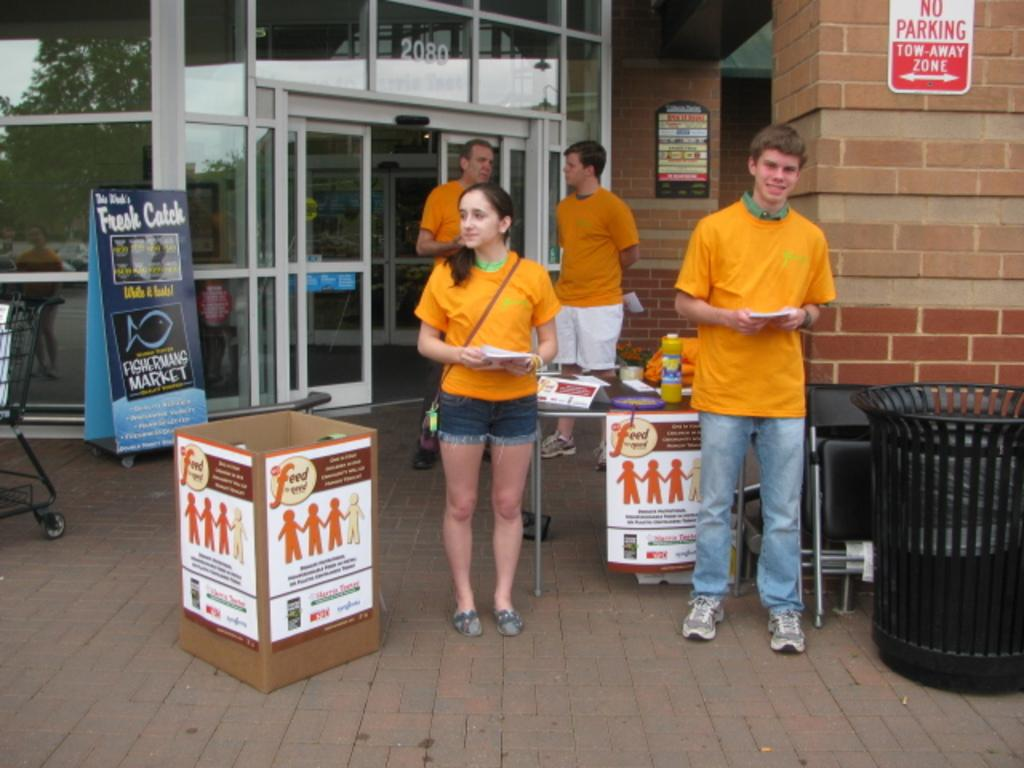<image>
Describe the image concisely. Kids in yellow shirts outside a store collecting donations for a charity that begins with Feed. 